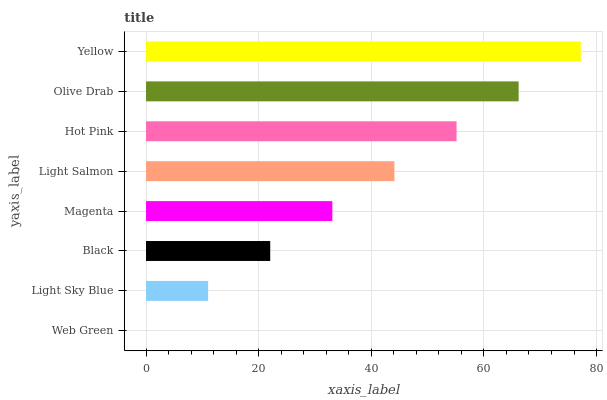Is Web Green the minimum?
Answer yes or no. Yes. Is Yellow the maximum?
Answer yes or no. Yes. Is Light Sky Blue the minimum?
Answer yes or no. No. Is Light Sky Blue the maximum?
Answer yes or no. No. Is Light Sky Blue greater than Web Green?
Answer yes or no. Yes. Is Web Green less than Light Sky Blue?
Answer yes or no. Yes. Is Web Green greater than Light Sky Blue?
Answer yes or no. No. Is Light Sky Blue less than Web Green?
Answer yes or no. No. Is Light Salmon the high median?
Answer yes or no. Yes. Is Magenta the low median?
Answer yes or no. Yes. Is Web Green the high median?
Answer yes or no. No. Is Light Salmon the low median?
Answer yes or no. No. 